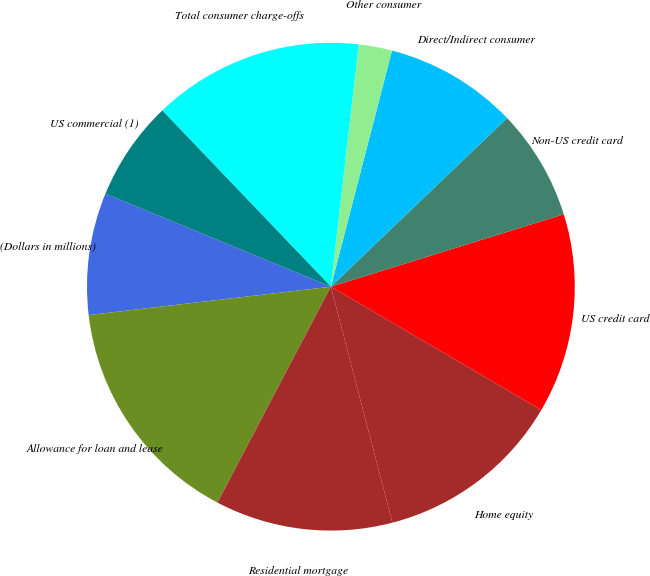<chart> <loc_0><loc_0><loc_500><loc_500><pie_chart><fcel>(Dollars in millions)<fcel>Allowance for loan and lease<fcel>Residential mortgage<fcel>Home equity<fcel>US credit card<fcel>Non-US credit card<fcel>Direct/Indirect consumer<fcel>Other consumer<fcel>Total consumer charge-offs<fcel>US commercial (1)<nl><fcel>8.09%<fcel>15.44%<fcel>11.76%<fcel>12.5%<fcel>13.24%<fcel>7.35%<fcel>8.82%<fcel>2.21%<fcel>13.97%<fcel>6.62%<nl></chart> 